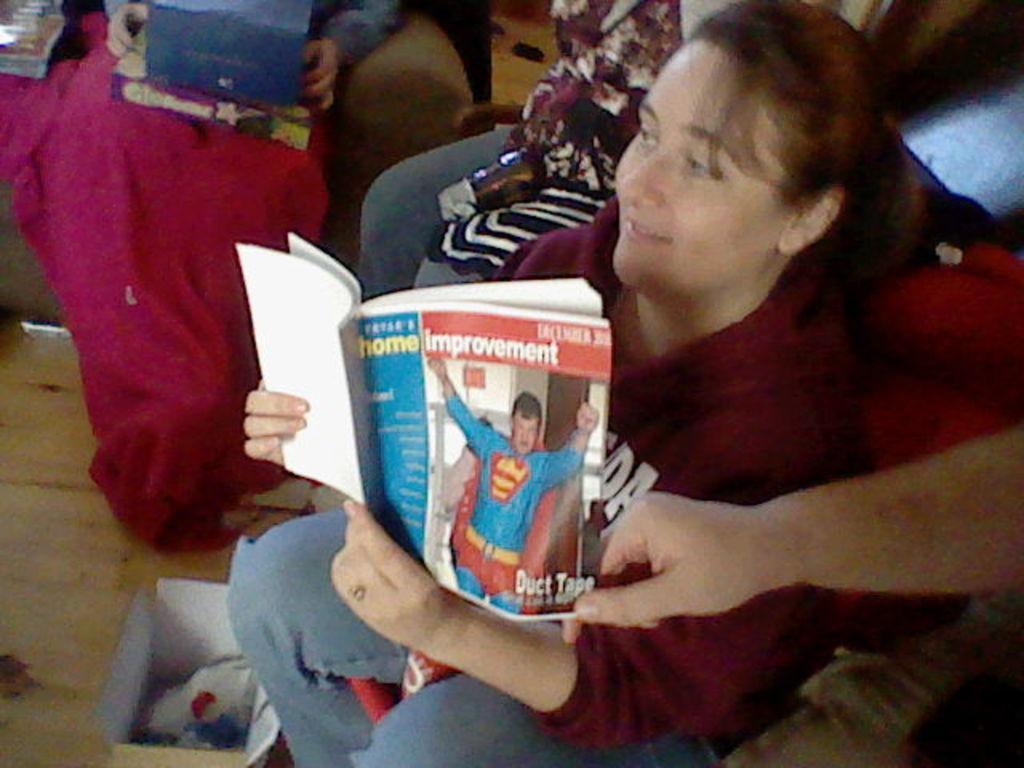Could you give a brief overview of what you see in this image? In this image I can see a person sitting and holding a book. The person is wearing red shirt, blue pant. Background I can see few other persons sitting and I can see a cardboard box. 